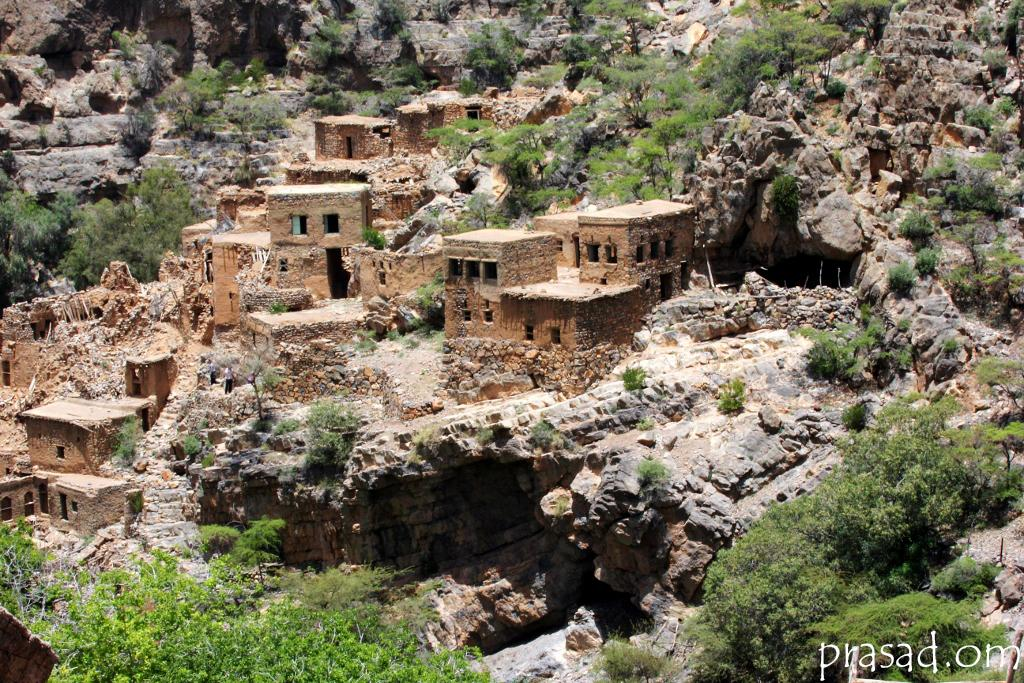What type of buildings are in the image? There are brick buildings in the image. Where are the brick buildings located? The brick buildings are on hills. What type of vegetation can be seen in the image? There are trees and plants in the image. What type of discussion is taking place in the jail in the image? There is no jail or discussion present in the image; it features brick buildings on hills with trees and plants. 